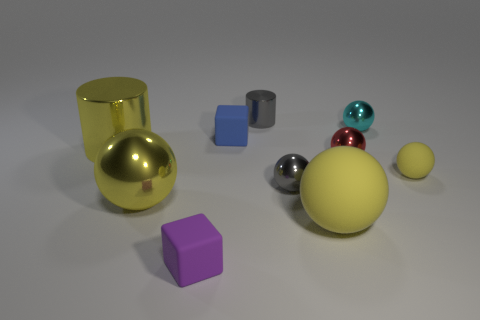Subtract all blue cylinders. How many yellow balls are left? 3 Subtract 2 spheres. How many spheres are left? 4 Subtract all cyan balls. How many balls are left? 5 Subtract all large spheres. How many spheres are left? 4 Subtract all gray spheres. Subtract all purple cylinders. How many spheres are left? 5 Subtract all cylinders. How many objects are left? 8 Add 1 blue matte things. How many blue matte things are left? 2 Add 8 large yellow matte balls. How many large yellow matte balls exist? 9 Subtract 0 red blocks. How many objects are left? 10 Subtract all tiny red metallic objects. Subtract all balls. How many objects are left? 3 